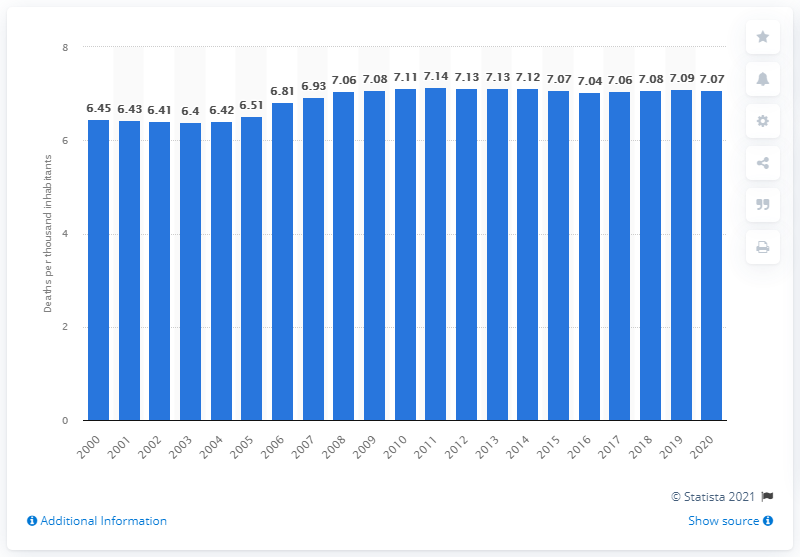Specify some key components in this picture. In 2020, the mortality rate in China was approximately 7.07 deaths per 1,000 inhabitants. 